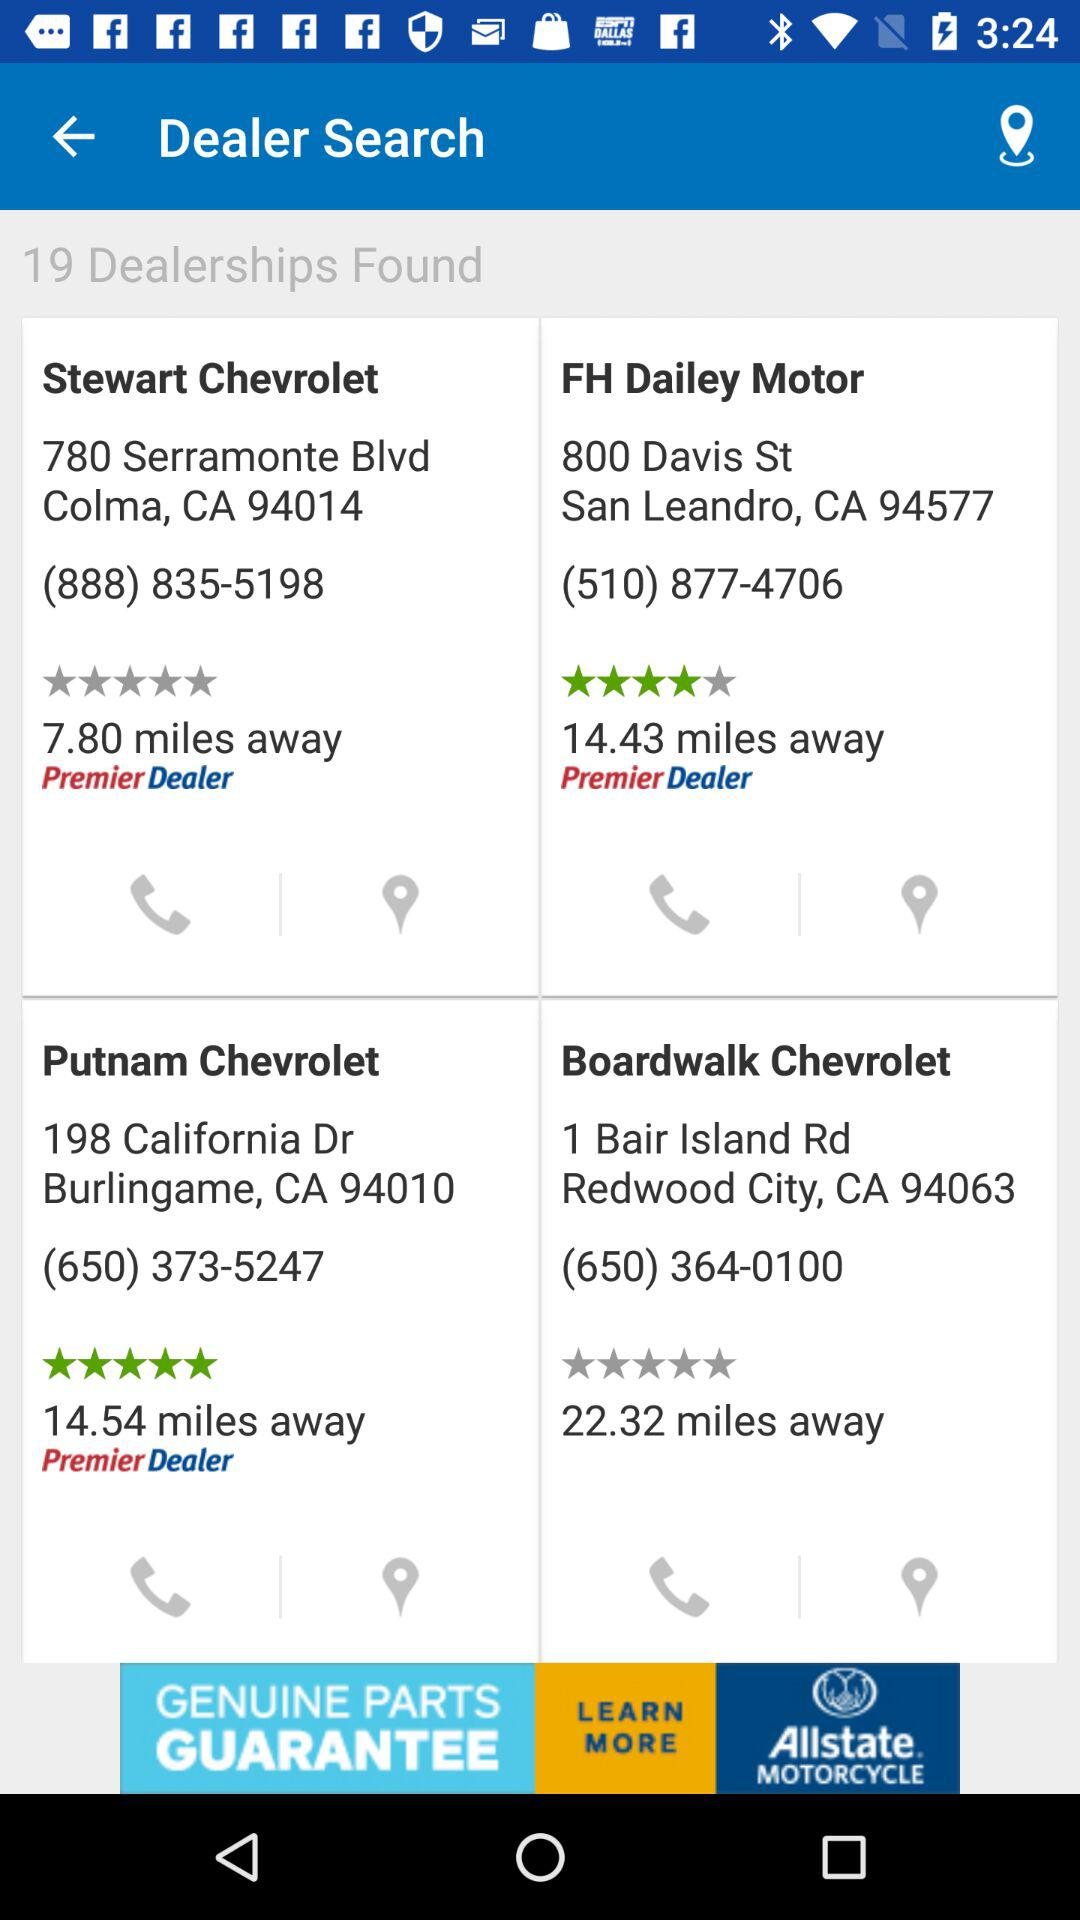What is the rating of "Putnam Chevrolet"? The rating of "Putnam Chevrolet" is 5 stars. 